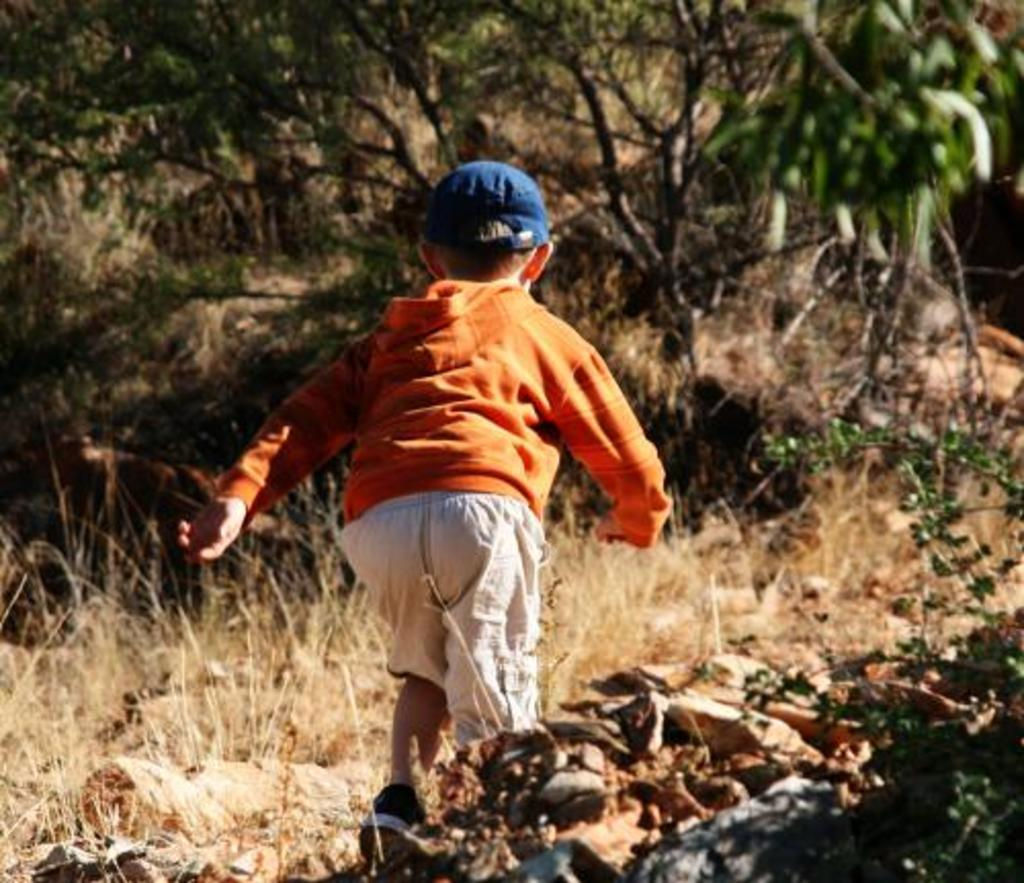What is the main subject of the image? The main subject of the image is a kid. What is the kid doing in the image? The kid is running in the image. What type of terrain is visible at the bottom of the image? There is grass and stones at the bottom of the image. What can be seen in the background of the image? There are trees in the background of the image. What is the kid wearing on their head? The kid is wearing a cap in the image. How many crows are sitting on the kid's shoulder in the image? There are no crows present in the image. What type of marble is the kid holding in their hand in the image? There is no marble visible in the image; the kid is running and not holding any objects. 